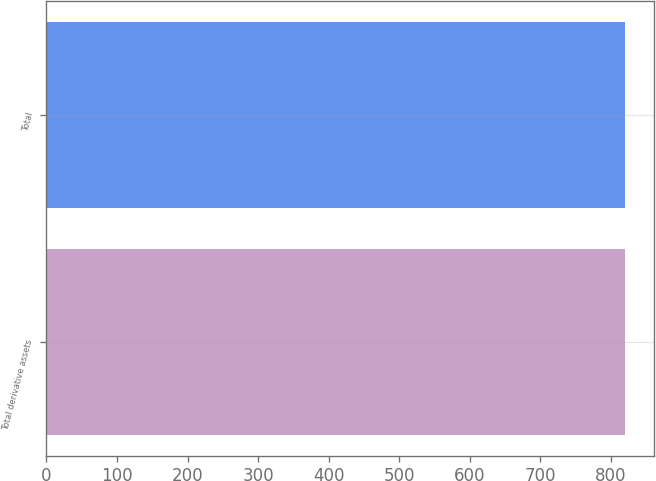<chart> <loc_0><loc_0><loc_500><loc_500><bar_chart><fcel>Total derivative assets<fcel>Total<nl><fcel>820<fcel>820.1<nl></chart> 